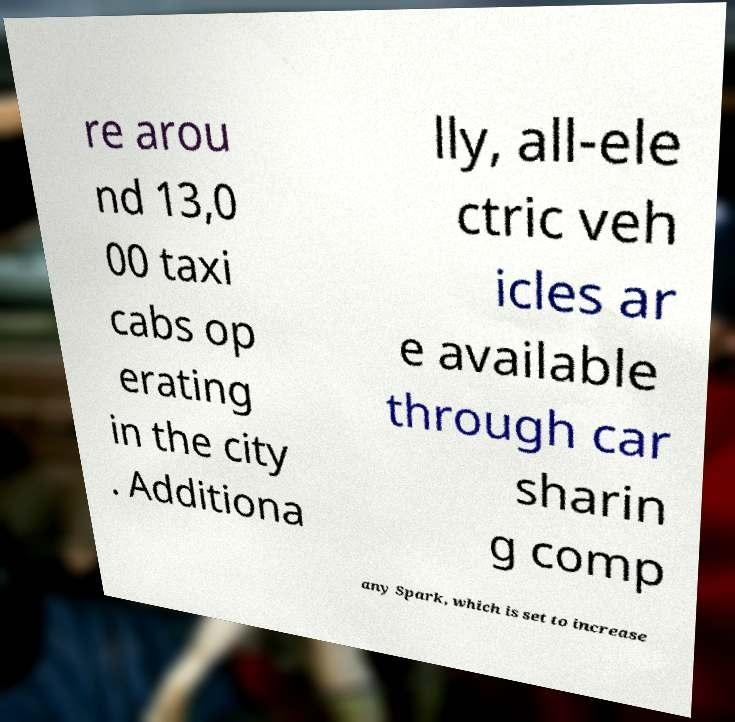Please identify and transcribe the text found in this image. re arou nd 13,0 00 taxi cabs op erating in the city . Additiona lly, all-ele ctric veh icles ar e available through car sharin g comp any Spark, which is set to increase 